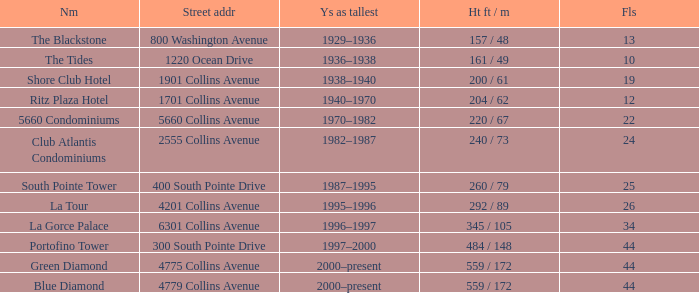How many years was the building with 24 floors the tallest? 1982–1987. 